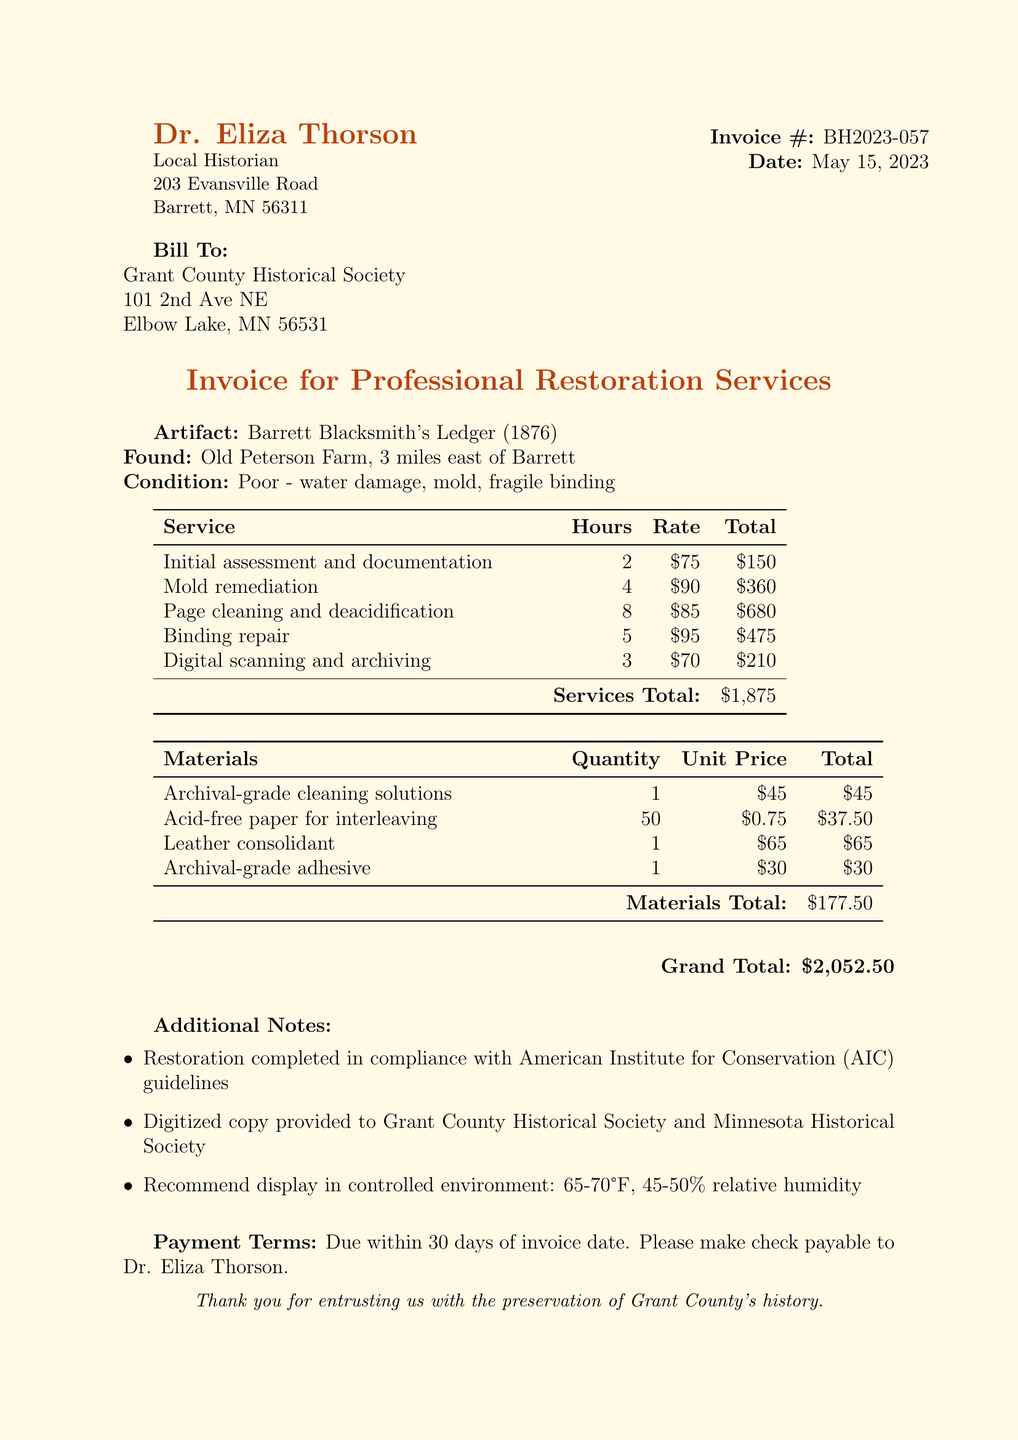What is the invoice number? The invoice number is listed at the top of the document as BH2023-057.
Answer: BH2023-057 Who is the historian? The historian's name is mentioned as Dr. Eliza Thorson in the document.
Answer: Dr. Eliza Thorson What is the total amount for materials used? The document states the total for materials used is $177.50.
Answer: $177.50 How many hours were spent on page cleaning and deacidification? The hours for page cleaning and deacidification can be found in the services list, which indicates 8 hours.
Answer: 8 What is the condition of the artifact? The document specifies the condition of the artifact as poor due to water damage, mold, and fragile binding.
Answer: Poor - water damage, mold, fragile binding What service had the highest hourly rate? By analyzing the services section, binding repair has the highest hourly rate of $95.
Answer: Binding repair What is the grand total of the invoice? The grand total is listed at the bottom of the document as $2,052.50.
Answer: $2,052.50 What is the payment term specified in the invoice? The payment terms are detailed in the document, stating payment is due within 30 days of the invoice date.
Answer: Due within 30 days of invoice date 